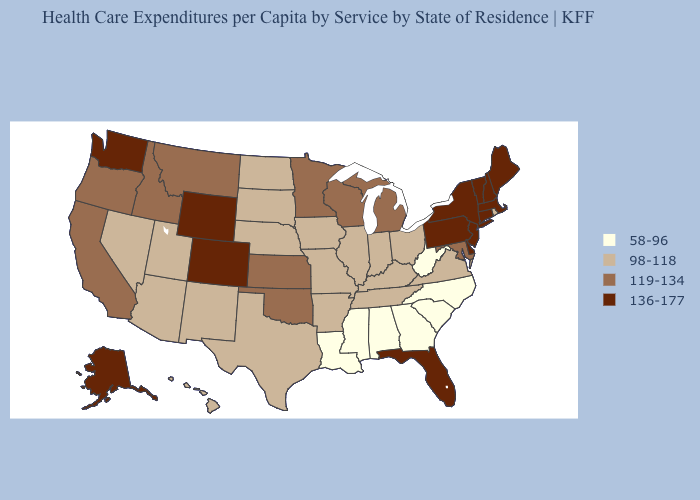Among the states that border Nevada , does Utah have the lowest value?
Quick response, please. Yes. Does the map have missing data?
Short answer required. No. Among the states that border Mississippi , does Arkansas have the highest value?
Be succinct. Yes. Does the map have missing data?
Write a very short answer. No. Does Indiana have a higher value than Georgia?
Short answer required. Yes. Among the states that border Delaware , which have the highest value?
Concise answer only. New Jersey, Pennsylvania. Does Wyoming have the highest value in the West?
Quick response, please. Yes. Does the map have missing data?
Answer briefly. No. Name the states that have a value in the range 136-177?
Give a very brief answer. Alaska, Colorado, Connecticut, Delaware, Florida, Maine, Massachusetts, New Hampshire, New Jersey, New York, Pennsylvania, Vermont, Washington, Wyoming. Does Hawaii have a higher value than Alabama?
Give a very brief answer. Yes. What is the value of Virginia?
Write a very short answer. 98-118. Which states have the lowest value in the South?
Be succinct. Alabama, Georgia, Louisiana, Mississippi, North Carolina, South Carolina, West Virginia. Does Georgia have the lowest value in the USA?
Concise answer only. Yes. Does South Dakota have the highest value in the MidWest?
Give a very brief answer. No. 